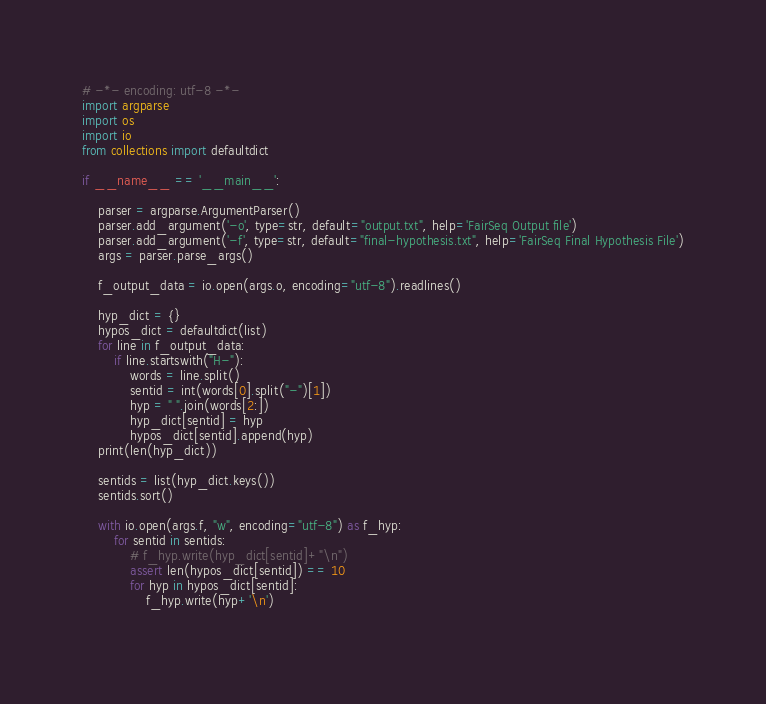<code> <loc_0><loc_0><loc_500><loc_500><_Python_># -*- encoding: utf-8 -*-
import argparse
import os
import io
from collections import defaultdict

if __name__ == '__main__':

    parser = argparse.ArgumentParser()
    parser.add_argument('-o', type=str, default="output.txt", help='FairSeq Output file')
    parser.add_argument('-f', type=str, default="final-hypothesis.txt", help='FairSeq Final Hypothesis File')
    args = parser.parse_args()

    f_output_data = io.open(args.o, encoding="utf-8").readlines()    

    hyp_dict = {}
    hypos_dict = defaultdict(list)
    for line in f_output_data:
        if line.startswith("H-"):
            words = line.split()
            sentid = int(words[0].split("-")[1])
            hyp = " ".join(words[2:])
            hyp_dict[sentid] = hyp
            hypos_dict[sentid].append(hyp)
    print(len(hyp_dict))

    sentids = list(hyp_dict.keys())
    sentids.sort()
    
    with io.open(args.f, "w", encoding="utf-8") as f_hyp:
        for sentid in sentids:
            # f_hyp.write(hyp_dict[sentid]+"\n")
            assert len(hypos_dict[sentid]) == 10
            for hyp in hypos_dict[sentid]:
                f_hyp.write(hyp+'\n')
            
</code> 